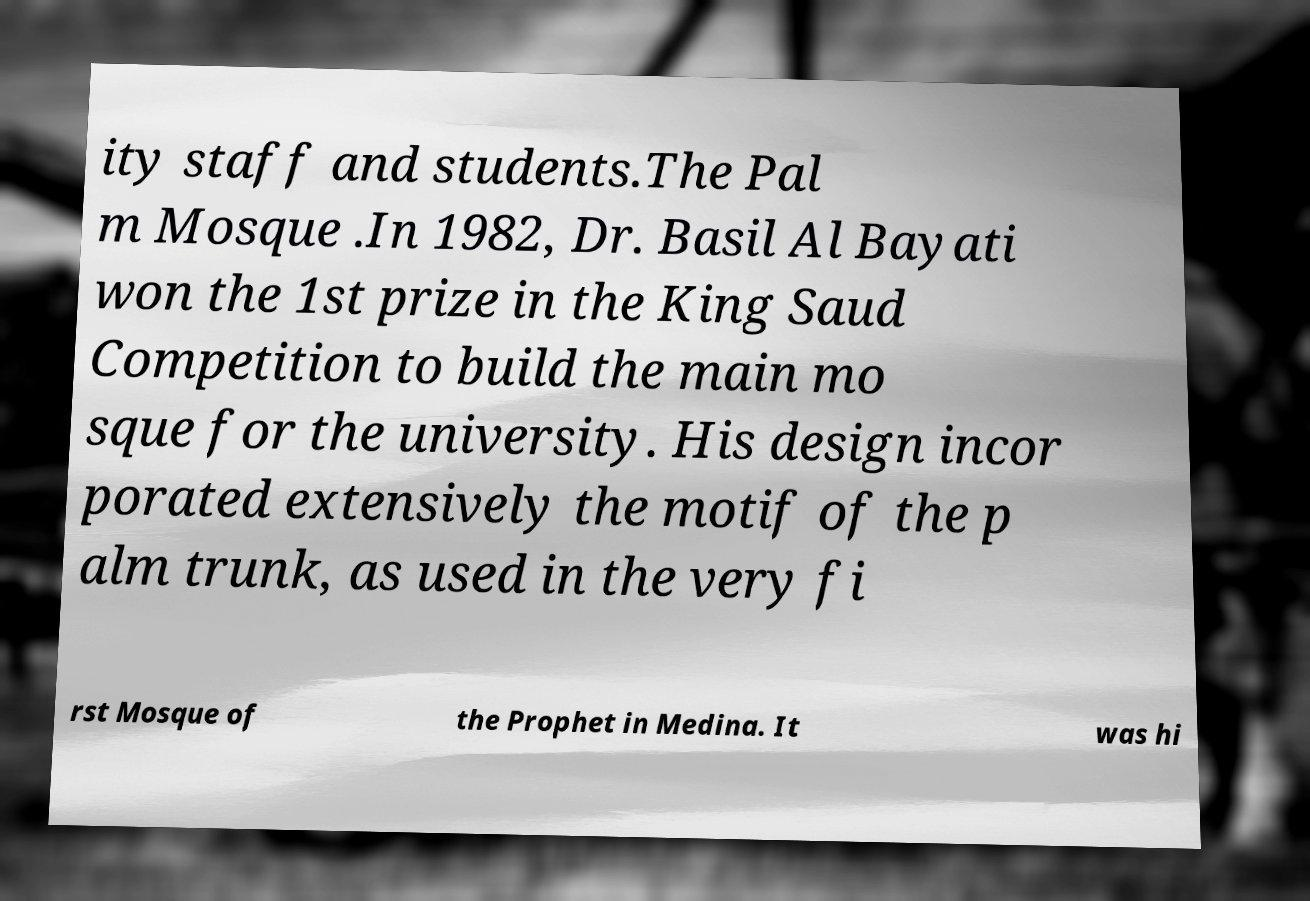Please identify and transcribe the text found in this image. ity staff and students.The Pal m Mosque .In 1982, Dr. Basil Al Bayati won the 1st prize in the King Saud Competition to build the main mo sque for the university. His design incor porated extensively the motif of the p alm trunk, as used in the very fi rst Mosque of the Prophet in Medina. It was hi 